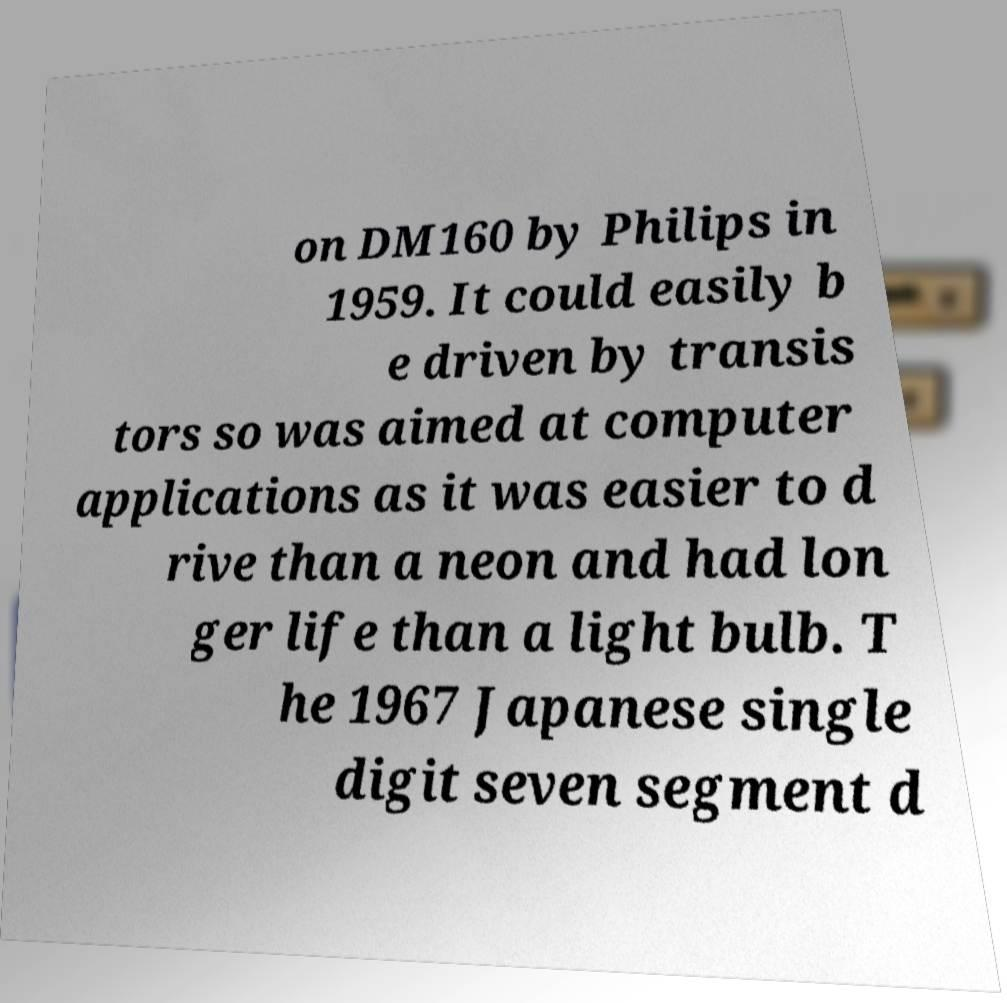For documentation purposes, I need the text within this image transcribed. Could you provide that? on DM160 by Philips in 1959. It could easily b e driven by transis tors so was aimed at computer applications as it was easier to d rive than a neon and had lon ger life than a light bulb. T he 1967 Japanese single digit seven segment d 